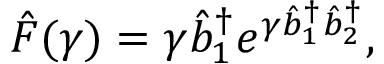Convert formula to latex. <formula><loc_0><loc_0><loc_500><loc_500>\hat { F } ( \gamma ) = \gamma \hat { b } _ { 1 } ^ { \dagger } e ^ { \gamma \hat { b } _ { 1 } ^ { \dagger } \hat { b } _ { 2 } ^ { \dagger } } ,</formula> 